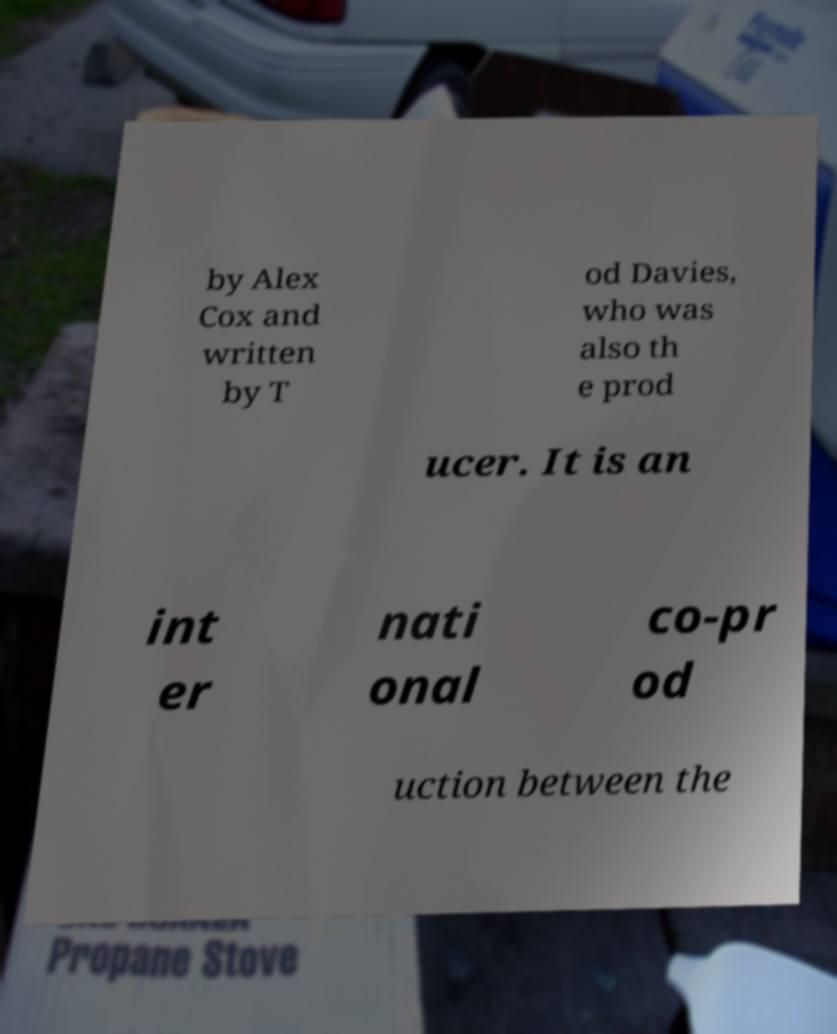What messages or text are displayed in this image? I need them in a readable, typed format. by Alex Cox and written by T od Davies, who was also th e prod ucer. It is an int er nati onal co-pr od uction between the 